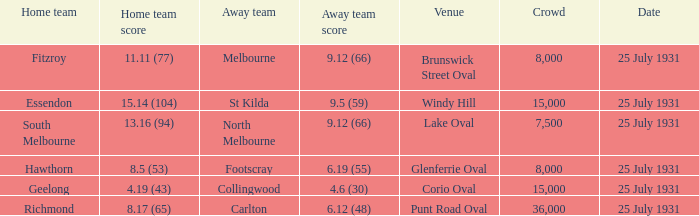When the home team was fitzroy, what was the away team's score? 9.12 (66). 